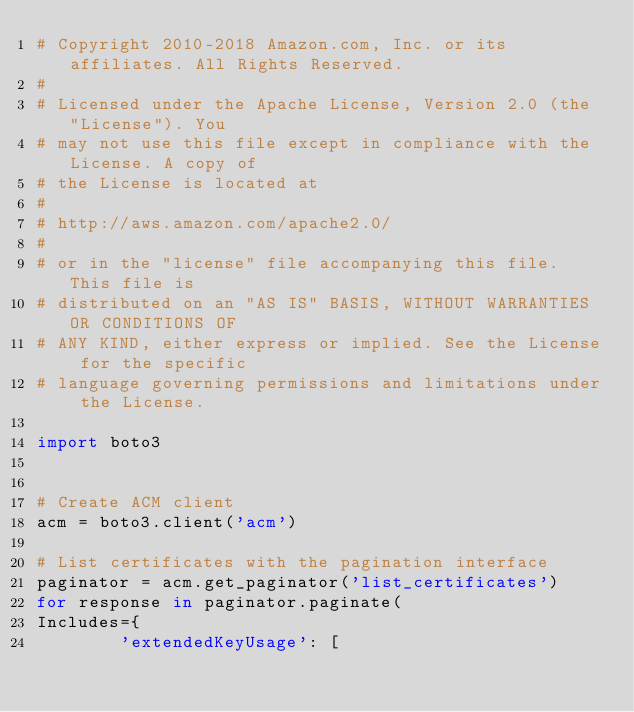<code> <loc_0><loc_0><loc_500><loc_500><_Python_># Copyright 2010-2018 Amazon.com, Inc. or its affiliates. All Rights Reserved.
#
# Licensed under the Apache License, Version 2.0 (the "License"). You
# may not use this file except in compliance with the License. A copy of
# the License is located at
#
# http://aws.amazon.com/apache2.0/
#
# or in the "license" file accompanying this file. This file is
# distributed on an "AS IS" BASIS, WITHOUT WARRANTIES OR CONDITIONS OF
# ANY KIND, either express or implied. See the License for the specific
# language governing permissions and limitations under the License.

import boto3


# Create ACM client
acm = boto3.client('acm')

# List certificates with the pagination interface
paginator = acm.get_paginator('list_certificates')
for response in paginator.paginate(
Includes={
        'extendedKeyUsage': [</code> 